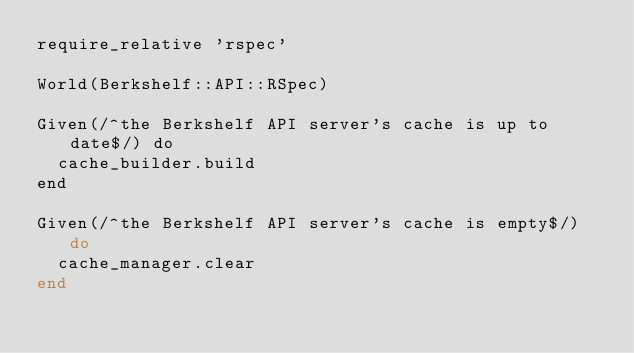Convert code to text. <code><loc_0><loc_0><loc_500><loc_500><_Ruby_>require_relative 'rspec'

World(Berkshelf::API::RSpec)

Given(/^the Berkshelf API server's cache is up to date$/) do
  cache_builder.build
end

Given(/^the Berkshelf API server's cache is empty$/) do
  cache_manager.clear
end
</code> 